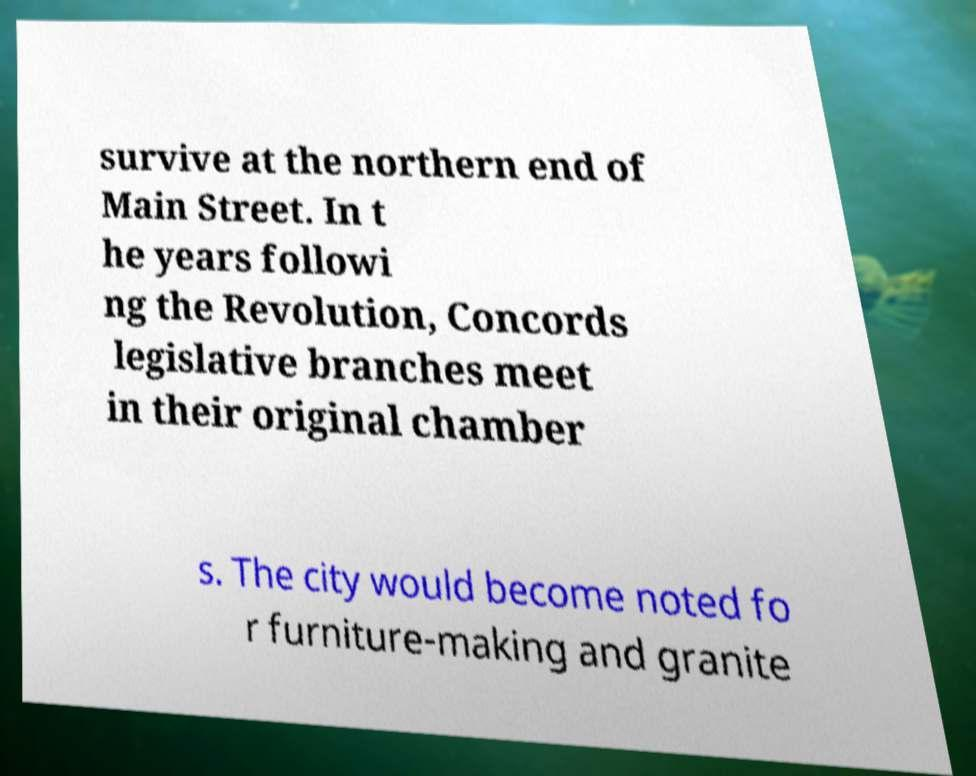Can you read and provide the text displayed in the image?This photo seems to have some interesting text. Can you extract and type it out for me? survive at the northern end of Main Street. In t he years followi ng the Revolution, Concords legislative branches meet in their original chamber s. The city would become noted fo r furniture-making and granite 